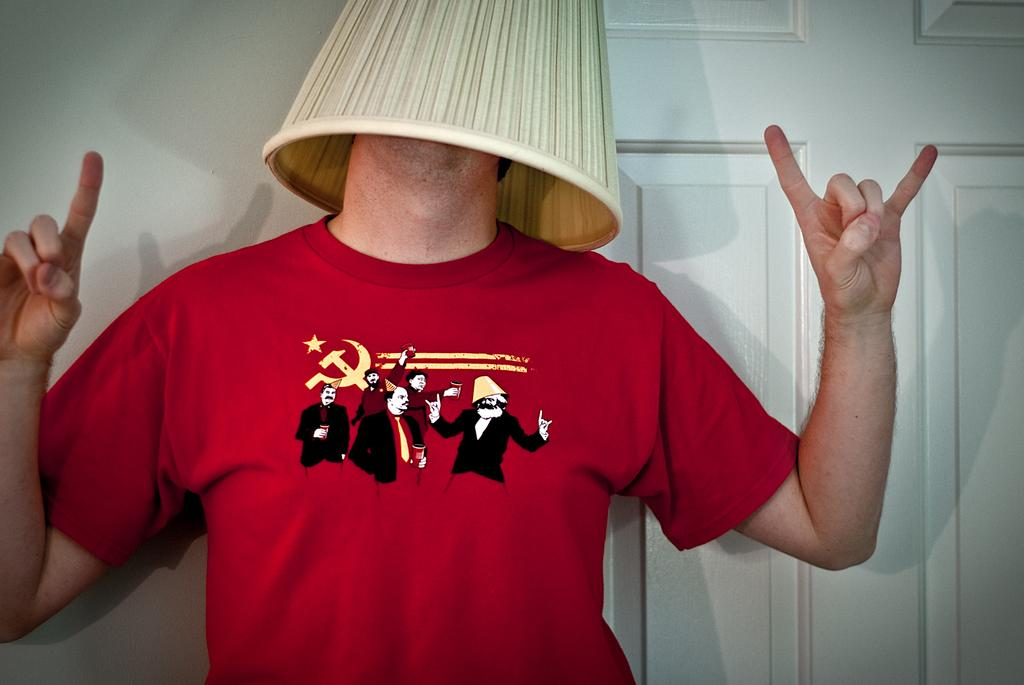What is the main subject of the image? There is a man standing in the center of the image. What is the man doing in the image? The man is covering his face with a white object. What can be seen in the background of the image? There is a door and a wall in the background of the image. What type of rice can be seen growing in the yard in the image? There is no rice or yard present in the image; it features a man covering his face with a white object and a door and wall in the background. 